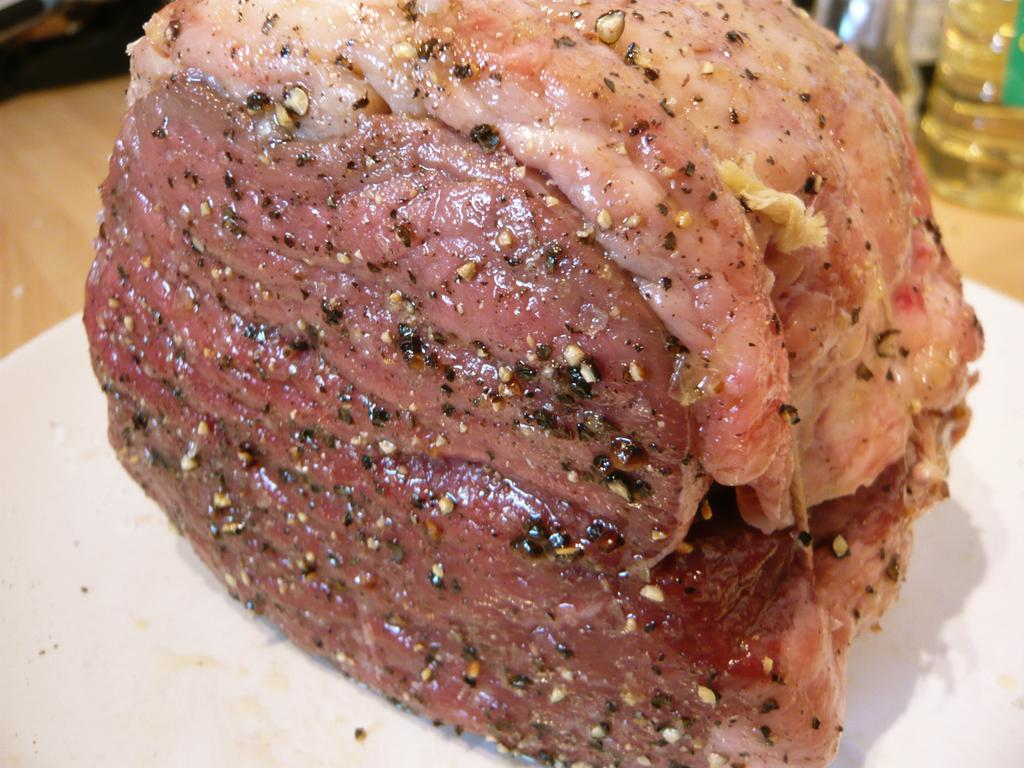What is on the plate that is visible in the image? There is meat on a plate in the image. Where is the plate located in the image? The plate is placed on a table. What else can be seen on the table in the image? There are bottles visible in the image. What type of police officer is standing near the window in the image? There is no police officer or window present in the image. What is the purpose of the meat on the plate in the image? The purpose of the meat on the plate cannot be determined from the image alone, as it could be for consumption, display, or any other reason. 